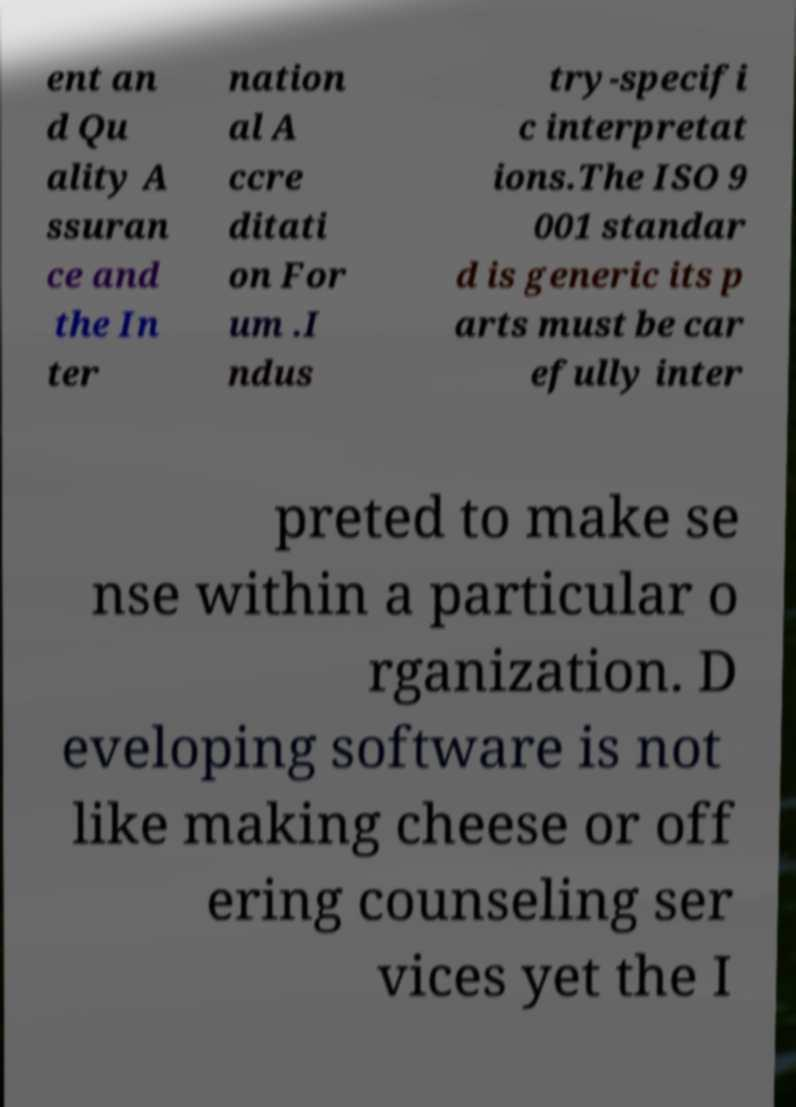For documentation purposes, I need the text within this image transcribed. Could you provide that? ent an d Qu ality A ssuran ce and the In ter nation al A ccre ditati on For um .I ndus try-specifi c interpretat ions.The ISO 9 001 standar d is generic its p arts must be car efully inter preted to make se nse within a particular o rganization. D eveloping software is not like making cheese or off ering counseling ser vices yet the I 